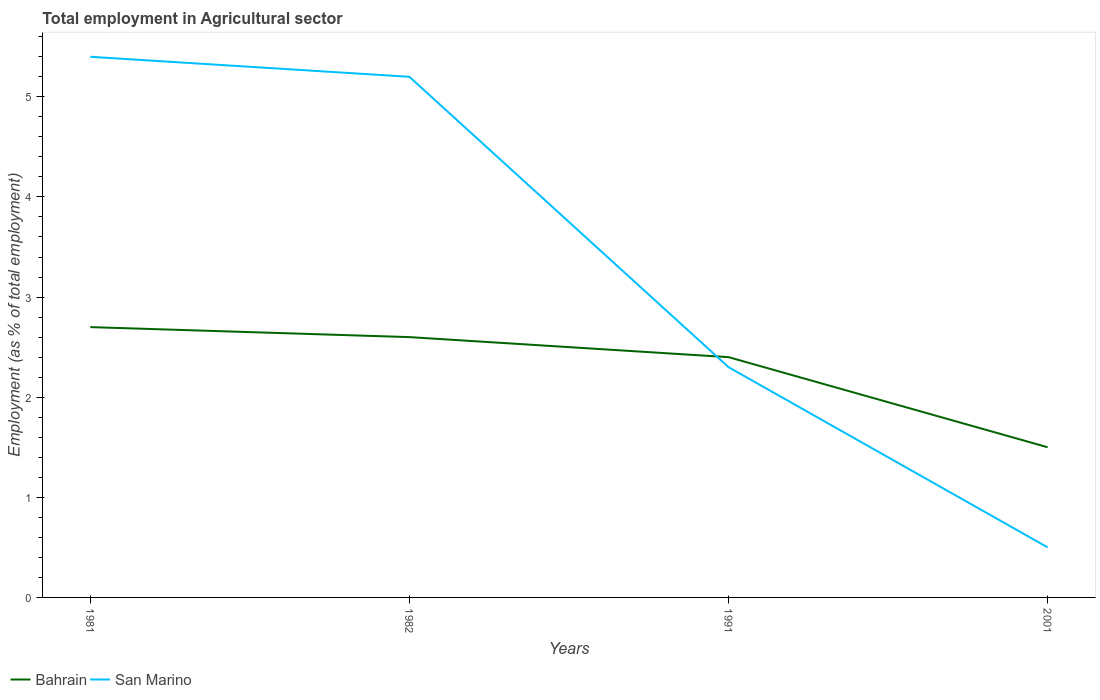How many different coloured lines are there?
Give a very brief answer. 2. Does the line corresponding to Bahrain intersect with the line corresponding to San Marino?
Provide a short and direct response. Yes. Is the number of lines equal to the number of legend labels?
Give a very brief answer. Yes. What is the total employment in agricultural sector in San Marino in the graph?
Offer a terse response. 0.2. What is the difference between the highest and the second highest employment in agricultural sector in San Marino?
Offer a terse response. 4.9. What is the difference between the highest and the lowest employment in agricultural sector in Bahrain?
Offer a very short reply. 3. Is the employment in agricultural sector in Bahrain strictly greater than the employment in agricultural sector in San Marino over the years?
Your response must be concise. No. How many lines are there?
Offer a terse response. 2. How many years are there in the graph?
Provide a succinct answer. 4. Are the values on the major ticks of Y-axis written in scientific E-notation?
Provide a succinct answer. No. Does the graph contain any zero values?
Your answer should be very brief. No. Does the graph contain grids?
Offer a very short reply. No. How many legend labels are there?
Your response must be concise. 2. What is the title of the graph?
Offer a terse response. Total employment in Agricultural sector. What is the label or title of the Y-axis?
Your response must be concise. Employment (as % of total employment). What is the Employment (as % of total employment) of Bahrain in 1981?
Your response must be concise. 2.7. What is the Employment (as % of total employment) of San Marino in 1981?
Your answer should be very brief. 5.4. What is the Employment (as % of total employment) of Bahrain in 1982?
Provide a succinct answer. 2.6. What is the Employment (as % of total employment) in San Marino in 1982?
Your response must be concise. 5.2. What is the Employment (as % of total employment) of Bahrain in 1991?
Keep it short and to the point. 2.4. What is the Employment (as % of total employment) in San Marino in 1991?
Your answer should be compact. 2.3. What is the Employment (as % of total employment) in Bahrain in 2001?
Provide a succinct answer. 1.5. What is the Employment (as % of total employment) of San Marino in 2001?
Offer a very short reply. 0.5. Across all years, what is the maximum Employment (as % of total employment) of Bahrain?
Provide a short and direct response. 2.7. Across all years, what is the maximum Employment (as % of total employment) of San Marino?
Provide a short and direct response. 5.4. Across all years, what is the minimum Employment (as % of total employment) of San Marino?
Provide a succinct answer. 0.5. What is the total Employment (as % of total employment) in San Marino in the graph?
Provide a short and direct response. 13.4. What is the difference between the Employment (as % of total employment) in Bahrain in 1981 and that in 1991?
Your answer should be compact. 0.3. What is the difference between the Employment (as % of total employment) in San Marino in 1981 and that in 1991?
Give a very brief answer. 3.1. What is the difference between the Employment (as % of total employment) of San Marino in 1981 and that in 2001?
Give a very brief answer. 4.9. What is the difference between the Employment (as % of total employment) of Bahrain in 1982 and that in 1991?
Make the answer very short. 0.2. What is the difference between the Employment (as % of total employment) in San Marino in 1982 and that in 1991?
Your answer should be very brief. 2.9. What is the difference between the Employment (as % of total employment) of San Marino in 1982 and that in 2001?
Ensure brevity in your answer.  4.7. What is the difference between the Employment (as % of total employment) of Bahrain in 1981 and the Employment (as % of total employment) of San Marino in 1982?
Give a very brief answer. -2.5. What is the difference between the Employment (as % of total employment) in Bahrain in 1981 and the Employment (as % of total employment) in San Marino in 2001?
Make the answer very short. 2.2. What is the difference between the Employment (as % of total employment) of Bahrain in 1982 and the Employment (as % of total employment) of San Marino in 1991?
Provide a succinct answer. 0.3. What is the average Employment (as % of total employment) in San Marino per year?
Your answer should be very brief. 3.35. In the year 1981, what is the difference between the Employment (as % of total employment) in Bahrain and Employment (as % of total employment) in San Marino?
Ensure brevity in your answer.  -2.7. In the year 2001, what is the difference between the Employment (as % of total employment) of Bahrain and Employment (as % of total employment) of San Marino?
Give a very brief answer. 1. What is the ratio of the Employment (as % of total employment) of Bahrain in 1981 to that in 1991?
Provide a succinct answer. 1.12. What is the ratio of the Employment (as % of total employment) in San Marino in 1981 to that in 1991?
Ensure brevity in your answer.  2.35. What is the ratio of the Employment (as % of total employment) of Bahrain in 1982 to that in 1991?
Your answer should be very brief. 1.08. What is the ratio of the Employment (as % of total employment) in San Marino in 1982 to that in 1991?
Your answer should be very brief. 2.26. What is the ratio of the Employment (as % of total employment) in Bahrain in 1982 to that in 2001?
Your response must be concise. 1.73. What is the ratio of the Employment (as % of total employment) of San Marino in 1982 to that in 2001?
Make the answer very short. 10.4. What is the ratio of the Employment (as % of total employment) in Bahrain in 1991 to that in 2001?
Ensure brevity in your answer.  1.6. What is the ratio of the Employment (as % of total employment) in San Marino in 1991 to that in 2001?
Your answer should be compact. 4.6. What is the difference between the highest and the second highest Employment (as % of total employment) in Bahrain?
Give a very brief answer. 0.1. What is the difference between the highest and the second highest Employment (as % of total employment) of San Marino?
Make the answer very short. 0.2. What is the difference between the highest and the lowest Employment (as % of total employment) of Bahrain?
Provide a short and direct response. 1.2. 